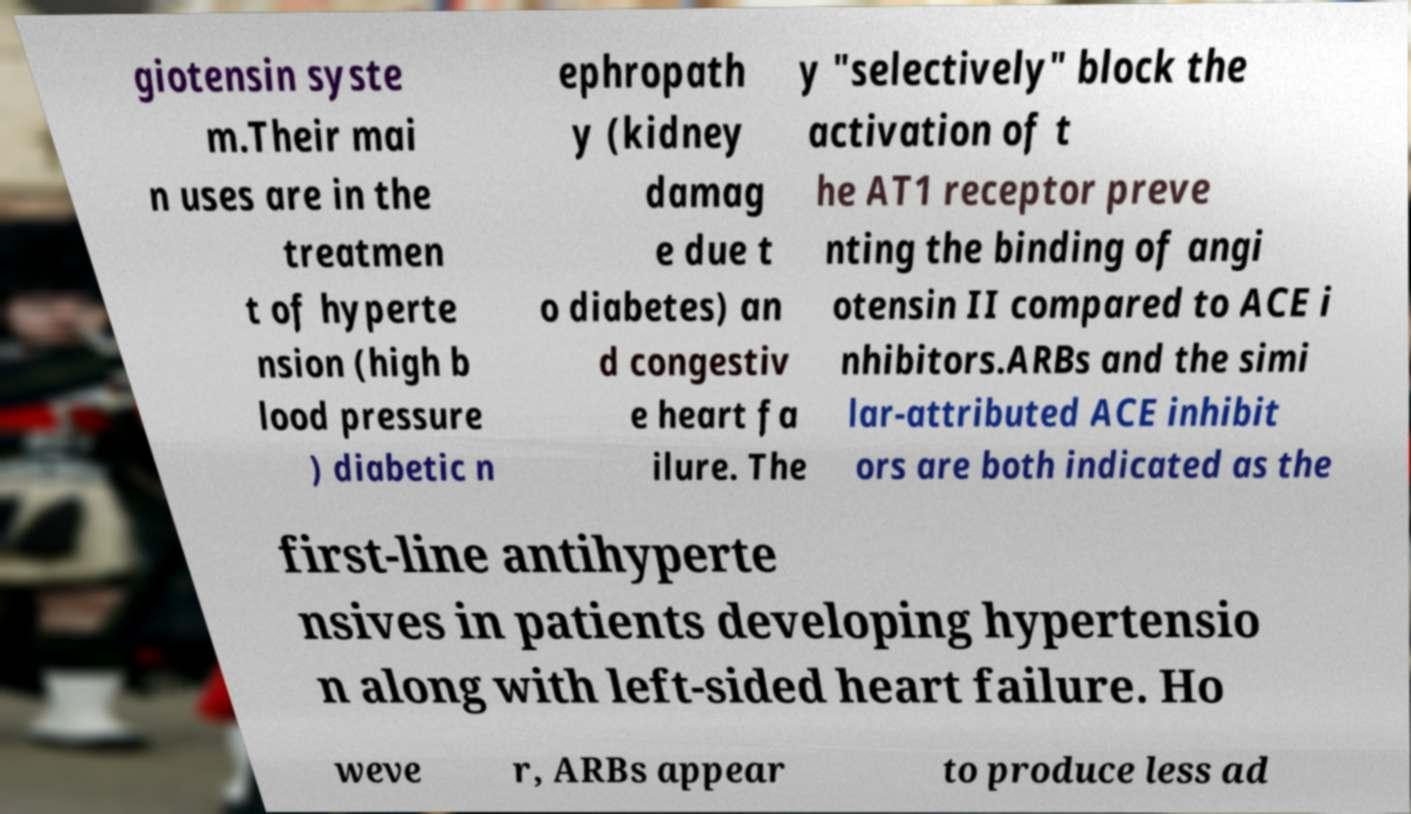I need the written content from this picture converted into text. Can you do that? giotensin syste m.Their mai n uses are in the treatmen t of hyperte nsion (high b lood pressure ) diabetic n ephropath y (kidney damag e due t o diabetes) an d congestiv e heart fa ilure. The y "selectively" block the activation of t he AT1 receptor preve nting the binding of angi otensin II compared to ACE i nhibitors.ARBs and the simi lar-attributed ACE inhibit ors are both indicated as the first-line antihyperte nsives in patients developing hypertensio n along with left-sided heart failure. Ho weve r, ARBs appear to produce less ad 